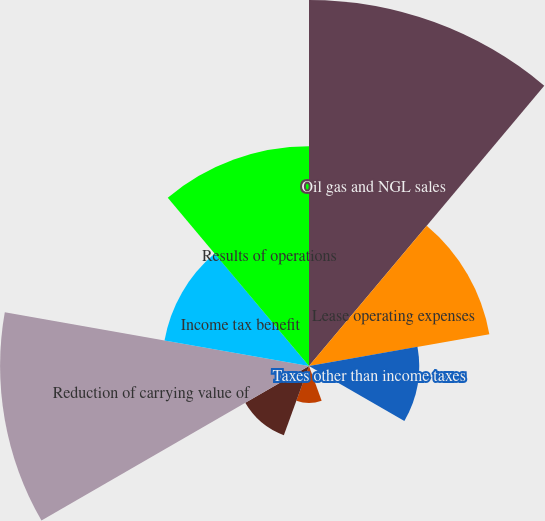<chart> <loc_0><loc_0><loc_500><loc_500><pie_chart><fcel>Oil gas and NGL sales<fcel>Lease operating expenses<fcel>Taxes other than income taxes<fcel>Depreciation depletion and<fcel>Accretion of asset retirement<fcel>General and administrative<fcel>Reduction of carrying value of<fcel>Income tax benefit<fcel>Results of operations<nl><fcel>25.32%<fcel>12.67%<fcel>7.62%<fcel>0.03%<fcel>2.56%<fcel>5.09%<fcel>21.37%<fcel>10.15%<fcel>15.2%<nl></chart> 